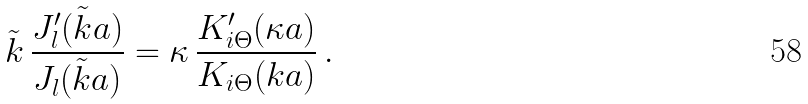Convert formula to latex. <formula><loc_0><loc_0><loc_500><loc_500>\tilde { k } \, \frac { J _ { l } ^ { \prime } ( \tilde { k } a ) } { J _ { l } ( \tilde { k } a ) } = \kappa \, \frac { K _ { i \Theta } ^ { \prime } ( \kappa a ) } { K _ { i \Theta } ( k a ) } \, .</formula> 